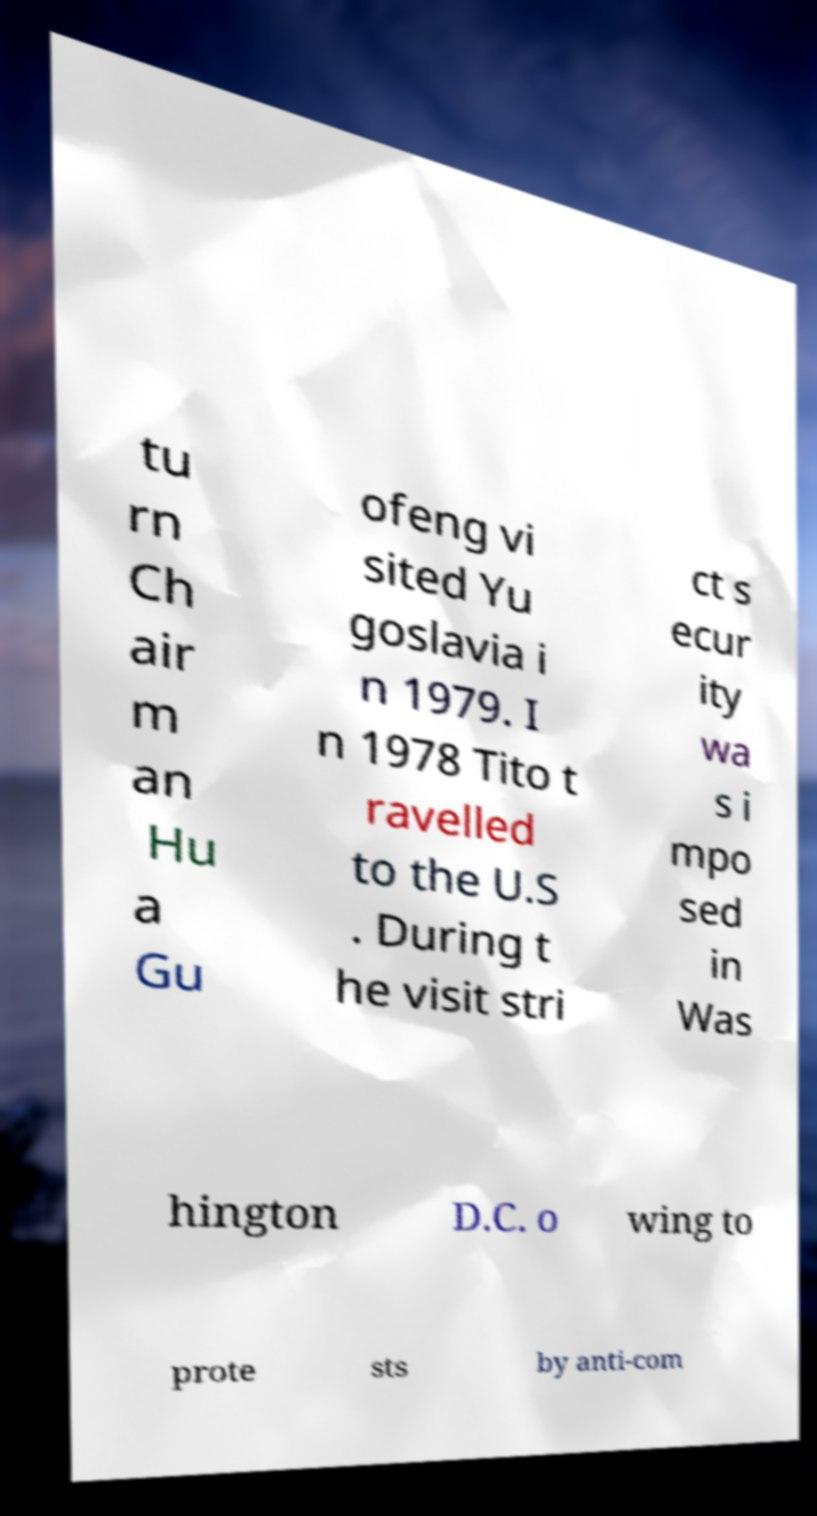Please identify and transcribe the text found in this image. tu rn Ch air m an Hu a Gu ofeng vi sited Yu goslavia i n 1979. I n 1978 Tito t ravelled to the U.S . During t he visit stri ct s ecur ity wa s i mpo sed in Was hington D.C. o wing to prote sts by anti-com 